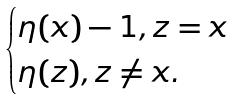<formula> <loc_0><loc_0><loc_500><loc_500>\begin{cases} \eta ( x ) - 1 , z = x \\ \eta ( z ) , z \neq x . \end{cases}</formula> 